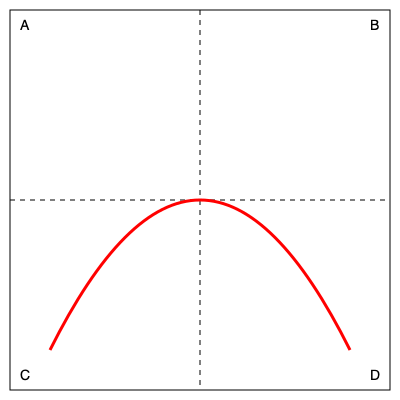Which rotation of the US-Mexico border wall blueprint would result in the most effective barrier against illegal crossings, considering the terrain and strategic placement? To determine the most effective rotation for the US-Mexico border wall blueprint, we need to consider the following factors:

1. Terrain: The curved line represents the natural terrain or obstacles along the border.
2. Strategic placement: The wall should be positioned to maximize coverage and minimize weak points.

Let's analyze each rotation:

A (Original position):
- The curve rises from left to right, potentially leaving gaps on the left side.
- This position may not effectively utilize natural barriers.

B (90° clockwise):
- The curve now descends from top to bottom, which could create vulnerabilities on the upper side.
- This orientation doesn't align well with typical border layout.

C (180° rotation):
- The curve now rises from right to left, potentially leaving gaps on the right side.
- This is essentially a mirror image of position A and offers no significant advantage.

D (90° counterclockwise):
- The curve ascends from bottom to top, following a more natural border layout.
- This position utilizes the terrain's natural barriers more effectively.
- It provides better coverage across the entire length of the wall.

Considering these factors, rotation D (90° counterclockwise) would result in the most effective barrier against illegal crossings. It aligns better with typical border layouts and maximizes the use of natural terrain features to enhance security.
Answer: 90° counterclockwise (Position D) 